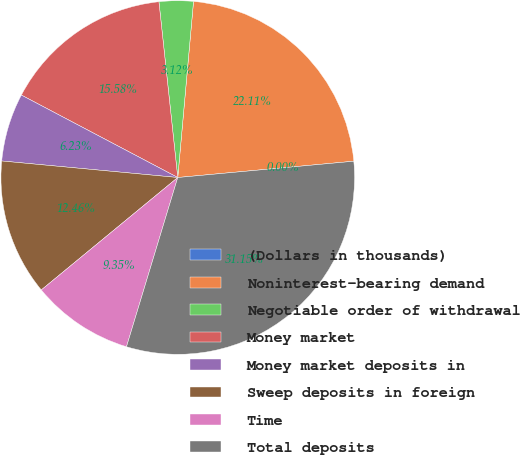Convert chart. <chart><loc_0><loc_0><loc_500><loc_500><pie_chart><fcel>(Dollars in thousands)<fcel>Noninterest-bearing demand<fcel>Negotiable order of withdrawal<fcel>Money market<fcel>Money market deposits in<fcel>Sweep deposits in foreign<fcel>Time<fcel>Total deposits<nl><fcel>0.0%<fcel>22.11%<fcel>3.12%<fcel>15.58%<fcel>6.23%<fcel>12.46%<fcel>9.35%<fcel>31.15%<nl></chart> 